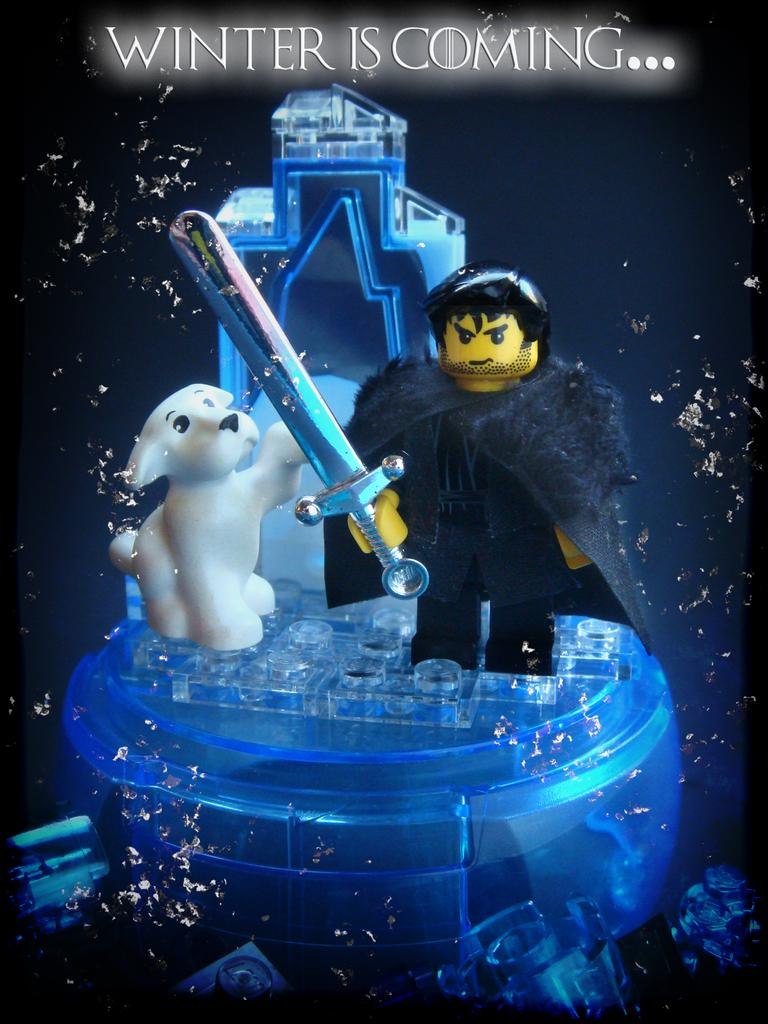What objects are placed on a stand in the image? There are toys placed on a stand in the image. What else can be seen in the image besides the toys on the stand? There is some text visible at the top of the image. Can you see any squirrels using their feet to open the lock in the image? There are no squirrels, feet, or locks present in the image. 